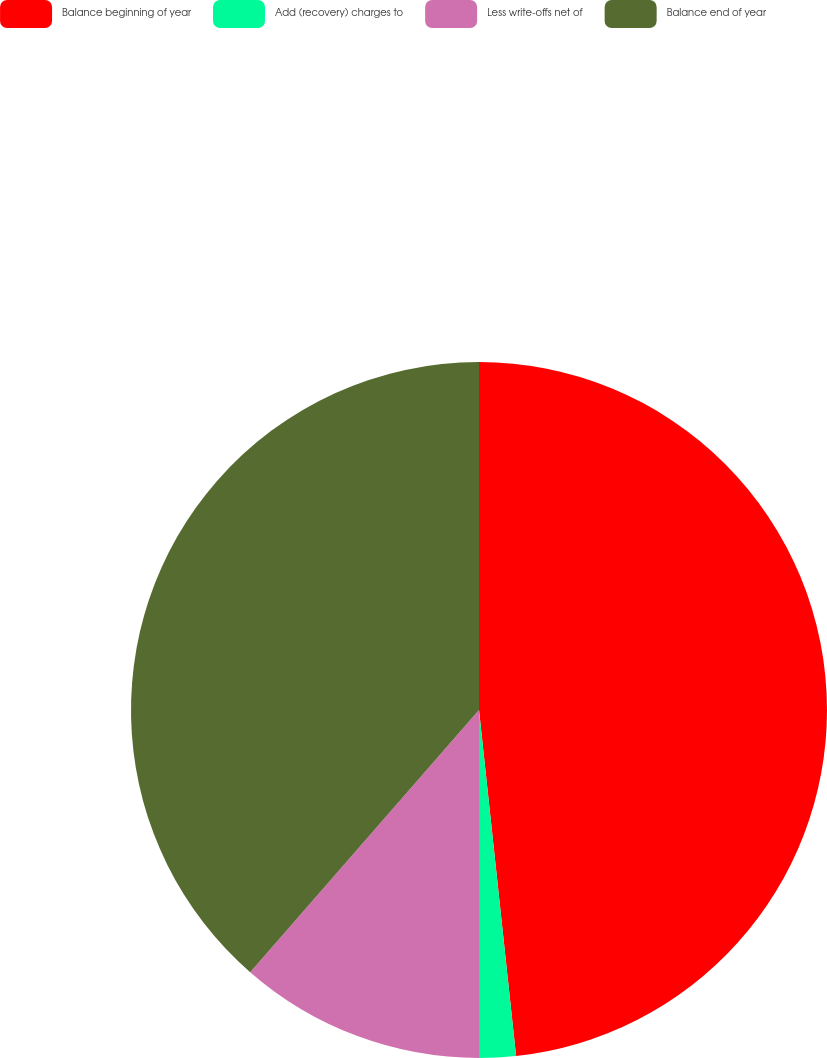<chart> <loc_0><loc_0><loc_500><loc_500><pie_chart><fcel>Balance beginning of year<fcel>Add (recovery) charges to<fcel>Less write-offs net of<fcel>Balance end of year<nl><fcel>48.3%<fcel>1.7%<fcel>11.42%<fcel>38.58%<nl></chart> 